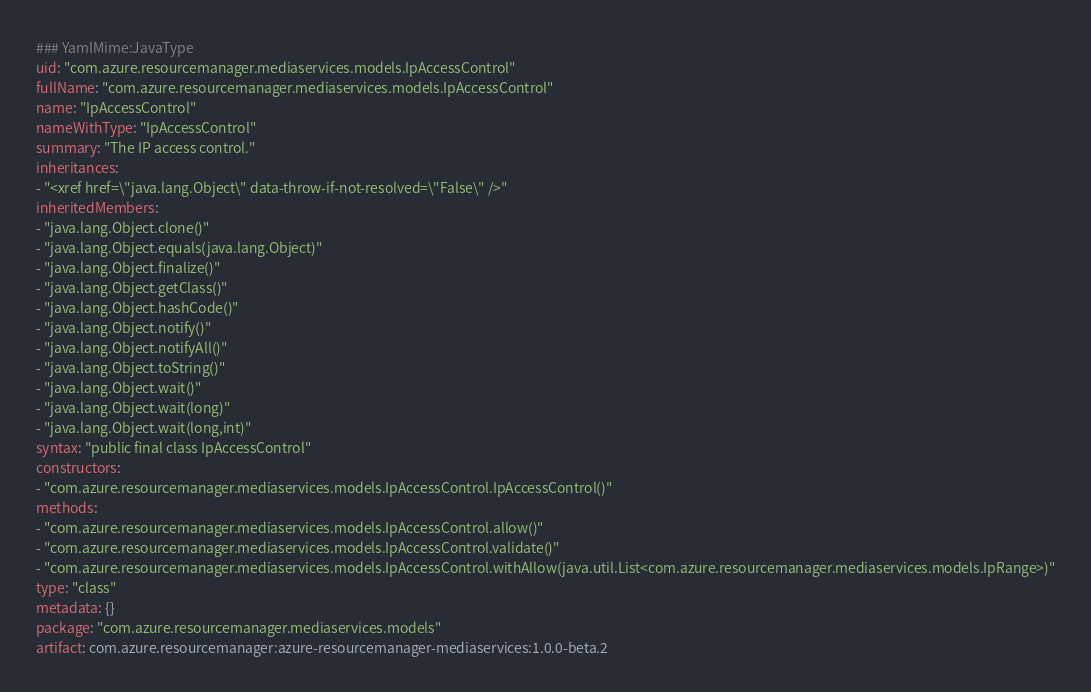<code> <loc_0><loc_0><loc_500><loc_500><_YAML_>### YamlMime:JavaType
uid: "com.azure.resourcemanager.mediaservices.models.IpAccessControl"
fullName: "com.azure.resourcemanager.mediaservices.models.IpAccessControl"
name: "IpAccessControl"
nameWithType: "IpAccessControl"
summary: "The IP access control."
inheritances:
- "<xref href=\"java.lang.Object\" data-throw-if-not-resolved=\"False\" />"
inheritedMembers:
- "java.lang.Object.clone()"
- "java.lang.Object.equals(java.lang.Object)"
- "java.lang.Object.finalize()"
- "java.lang.Object.getClass()"
- "java.lang.Object.hashCode()"
- "java.lang.Object.notify()"
- "java.lang.Object.notifyAll()"
- "java.lang.Object.toString()"
- "java.lang.Object.wait()"
- "java.lang.Object.wait(long)"
- "java.lang.Object.wait(long,int)"
syntax: "public final class IpAccessControl"
constructors:
- "com.azure.resourcemanager.mediaservices.models.IpAccessControl.IpAccessControl()"
methods:
- "com.azure.resourcemanager.mediaservices.models.IpAccessControl.allow()"
- "com.azure.resourcemanager.mediaservices.models.IpAccessControl.validate()"
- "com.azure.resourcemanager.mediaservices.models.IpAccessControl.withAllow(java.util.List<com.azure.resourcemanager.mediaservices.models.IpRange>)"
type: "class"
metadata: {}
package: "com.azure.resourcemanager.mediaservices.models"
artifact: com.azure.resourcemanager:azure-resourcemanager-mediaservices:1.0.0-beta.2
</code> 